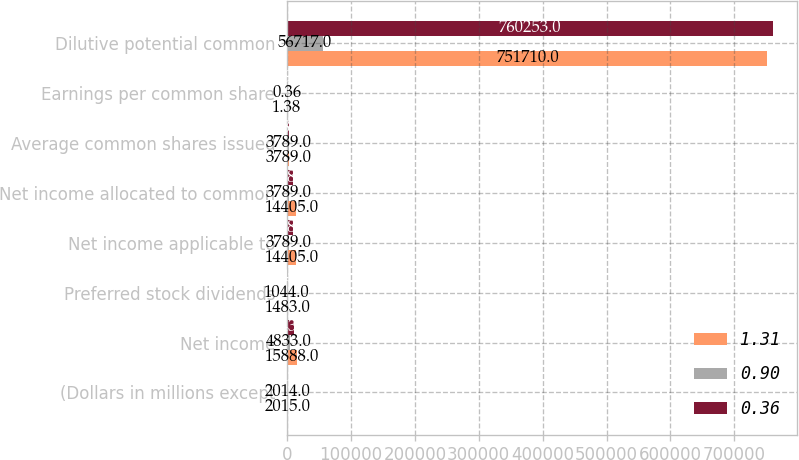<chart> <loc_0><loc_0><loc_500><loc_500><stacked_bar_chart><ecel><fcel>(Dollars in millions except<fcel>Net income<fcel>Preferred stock dividends<fcel>Net income applicable to<fcel>Net income allocated to common<fcel>Average common shares issued<fcel>Earnings per common share<fcel>Dilutive potential common<nl><fcel>1.31<fcel>2015<fcel>15888<fcel>1483<fcel>14405<fcel>14405<fcel>3789<fcel>1.38<fcel>751710<nl><fcel>0.9<fcel>2014<fcel>4833<fcel>1044<fcel>3789<fcel>3789<fcel>3789<fcel>0.36<fcel>56717<nl><fcel>0.36<fcel>2013<fcel>11431<fcel>1349<fcel>10082<fcel>10080<fcel>3789<fcel>0.94<fcel>760253<nl></chart> 